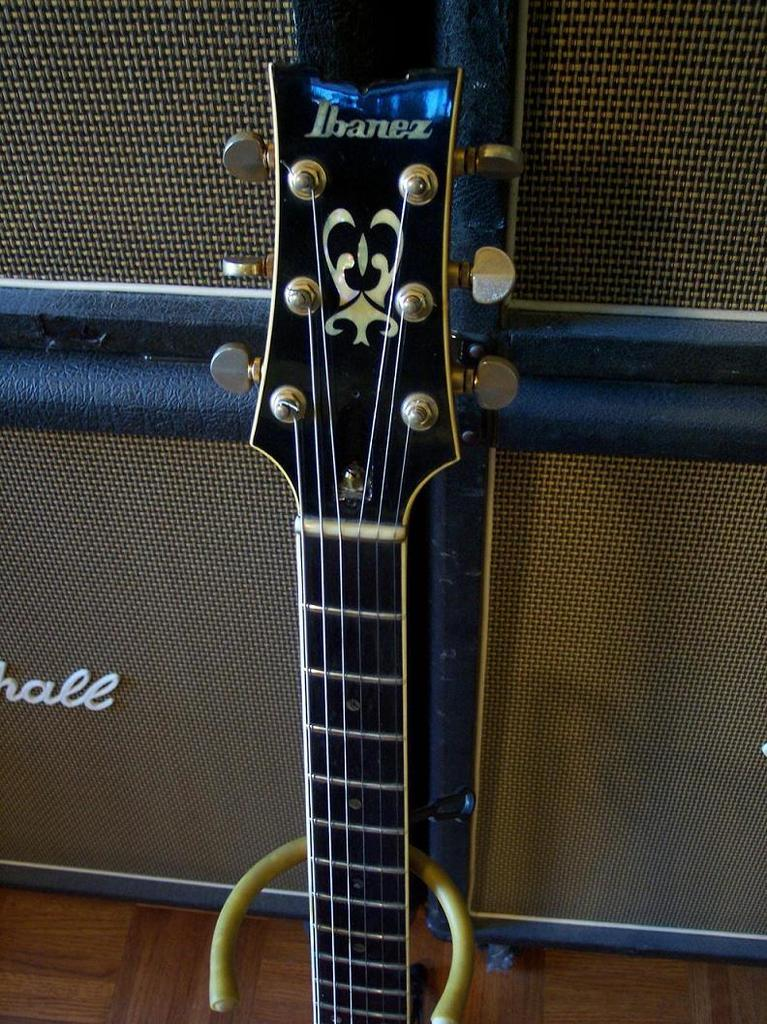What is the main subject of the image? The main subject of the image is a guitar head. Can you describe the background of the image? There is a wall in the background of the image. What type of creature is resting on the guitar head in the image? There is no creature present in the image, and the guitar head is not being used for resting. 